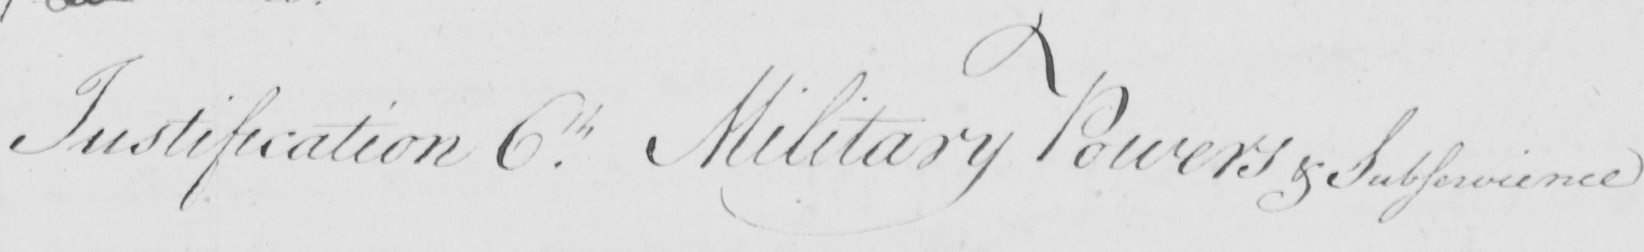Can you tell me what this handwritten text says? Justification 6.th Military Powers & Subservience 